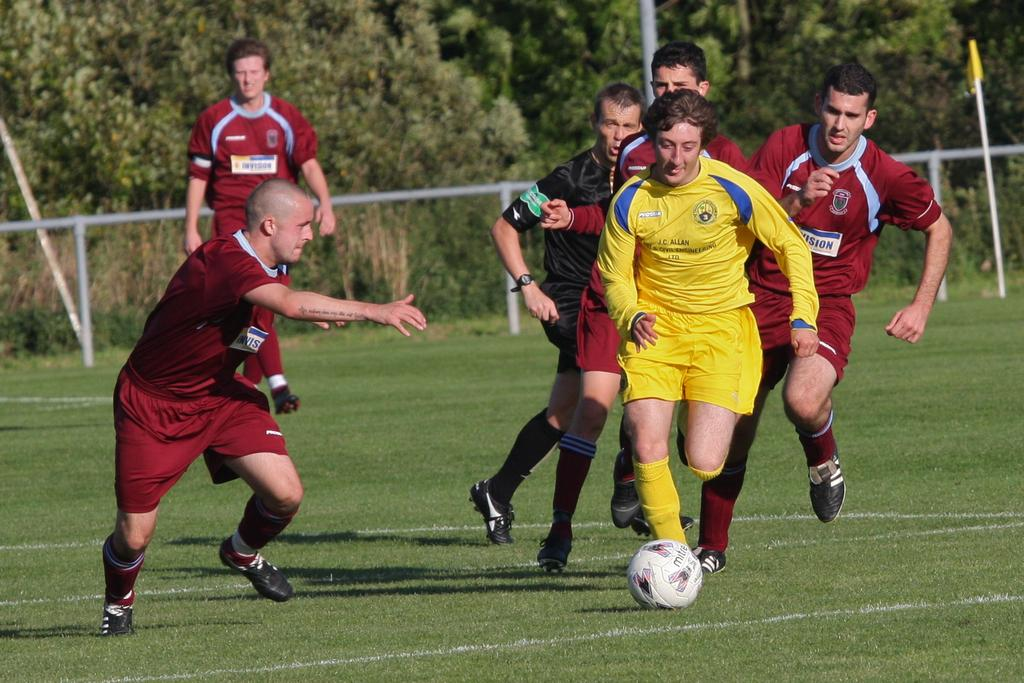What is happening in the center of the image? There are players in the center of the image. What object is located at the bottom of the image? There is a ball in the bottom of the image. What can be seen in the distance behind the players? There are trees visible in the background of the image. What type of root can be seen growing from the ball in the image? There is no root growing from the ball in the image; it is a ball used in a game. How does the heat affect the players in the image? The provided facts do not mention any heat or temperature, so we cannot determine how it affects the players in the image. 